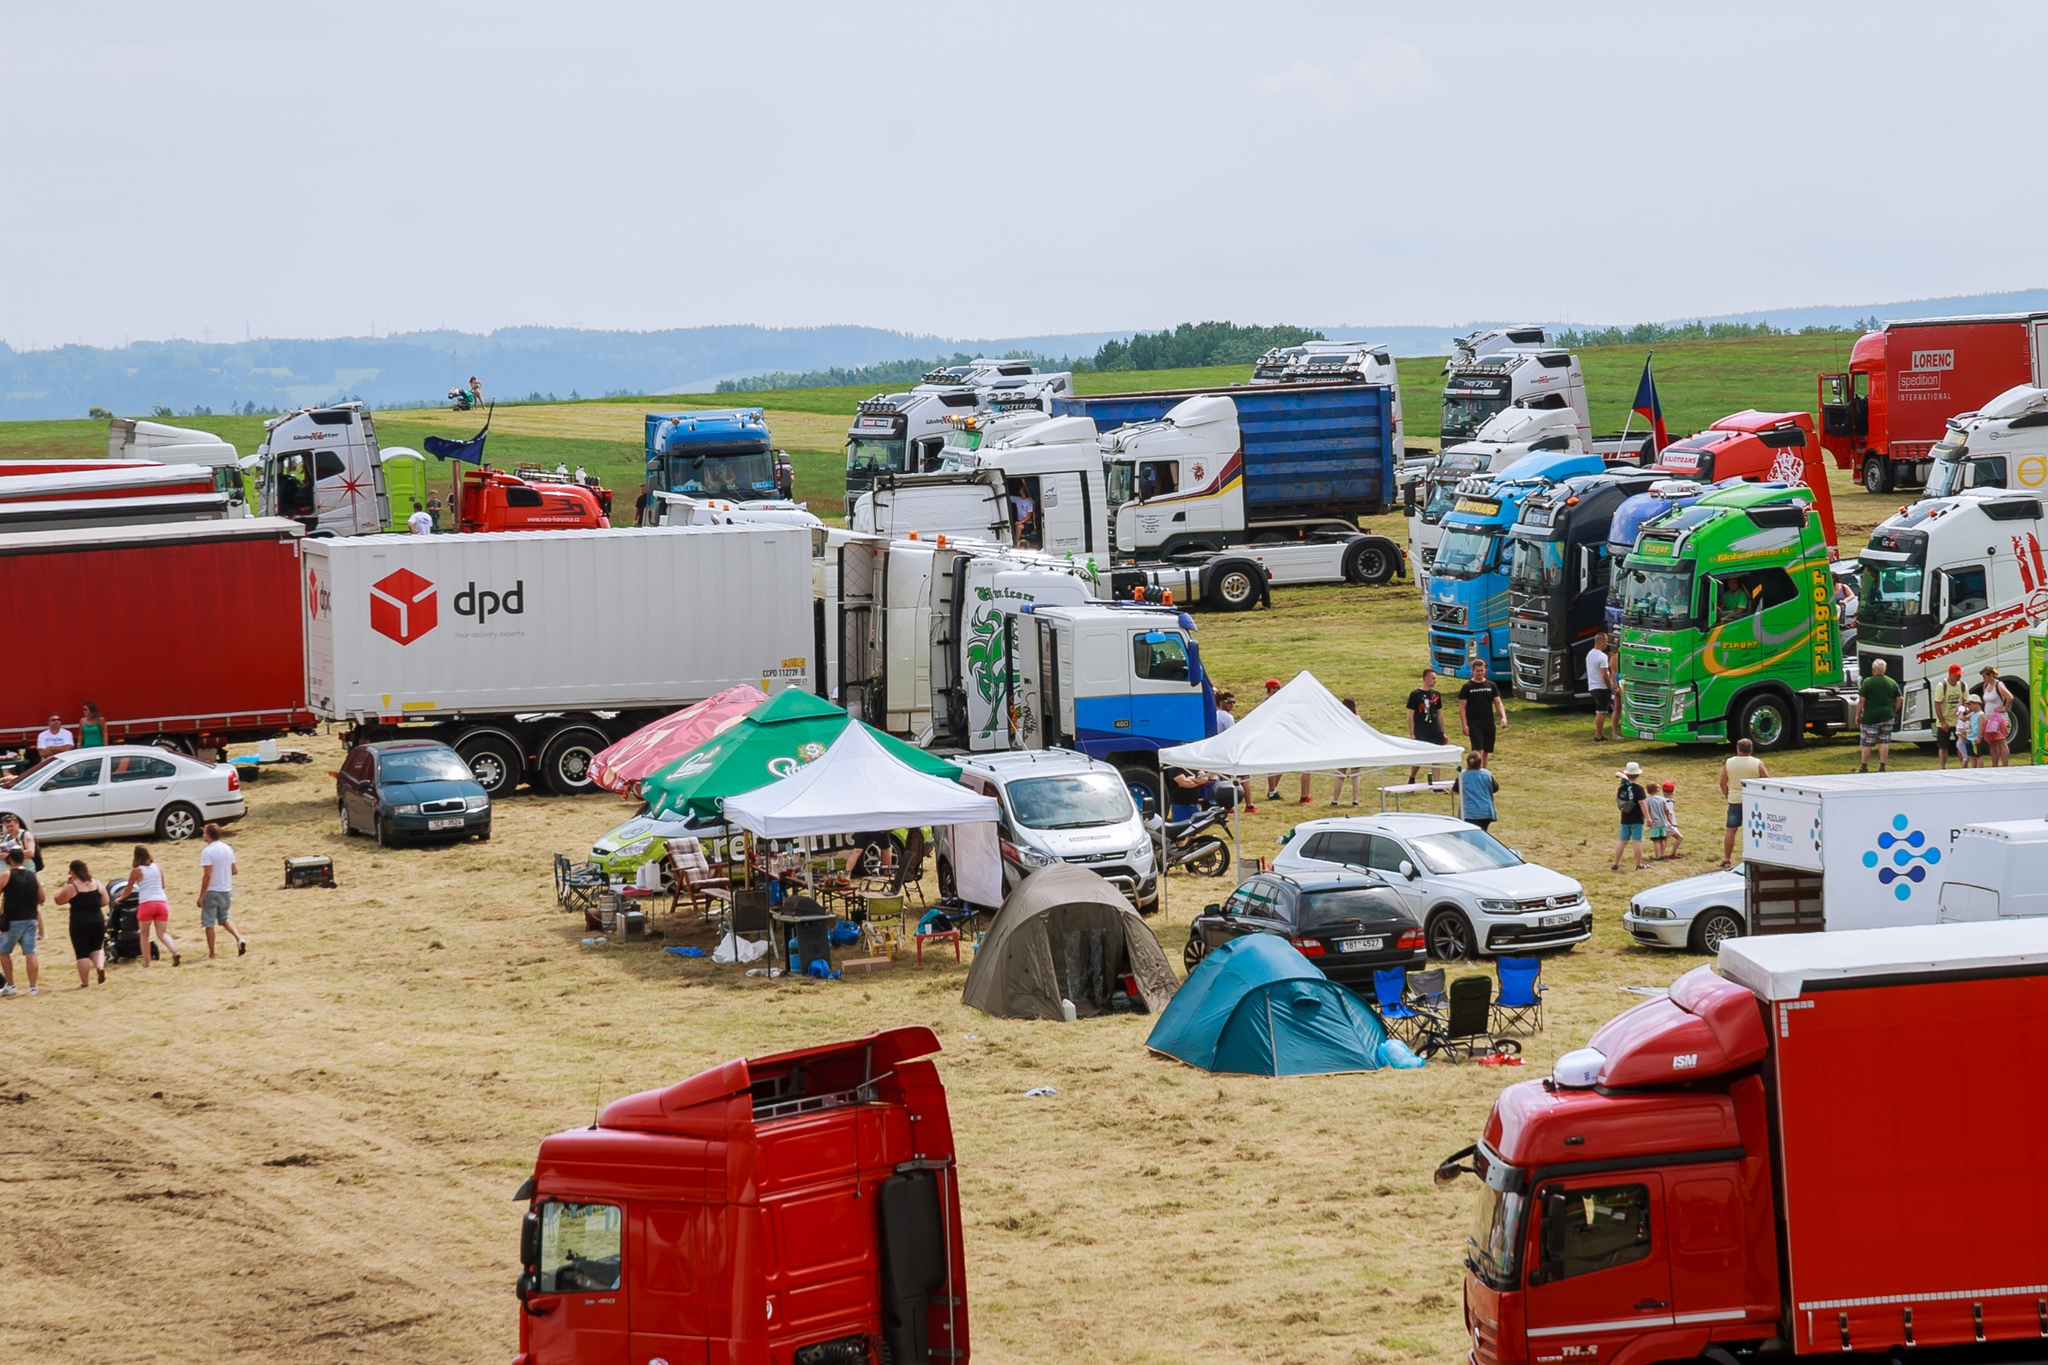What is this photo about? This photo captures a dynamic outdoor truck show or gathering, set in a large, grassy field. Dozens of trucks, each varying in color, size, and design, are parked in an organized yet scattered arrangement. Notably, some trucks promote their identity with bold logos and colors, indicative of a commercial or promotional event. Nestled among these heavy vehicles are smaller tents and cars, adding a casual, festive atmosphere to the scene. The setting is rural, under an overcast sky, suggesting a special event rather than routine activity. The occasion could be a trade show, a truckers' meetup, or a community event focusing on automotive and transport themes. 